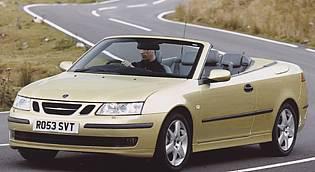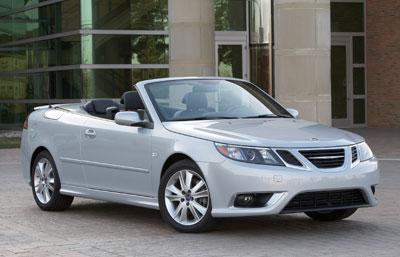The first image is the image on the left, the second image is the image on the right. Considering the images on both sides, is "Two convertibles with black interior are facing foreward in different directions, both with chrome wheels, but only one with a license plate." valid? Answer yes or no. Yes. The first image is the image on the left, the second image is the image on the right. Examine the images to the left and right. Is the description "Both left and right images contain a topless convertible facing forward, but only the car on the left has a driver behind the wheel." accurate? Answer yes or no. Yes. 